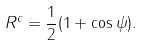Convert formula to latex. <formula><loc_0><loc_0><loc_500><loc_500>R ^ { c } = { \frac { 1 } { 2 } } ( 1 + \cos { \psi } ) .</formula> 